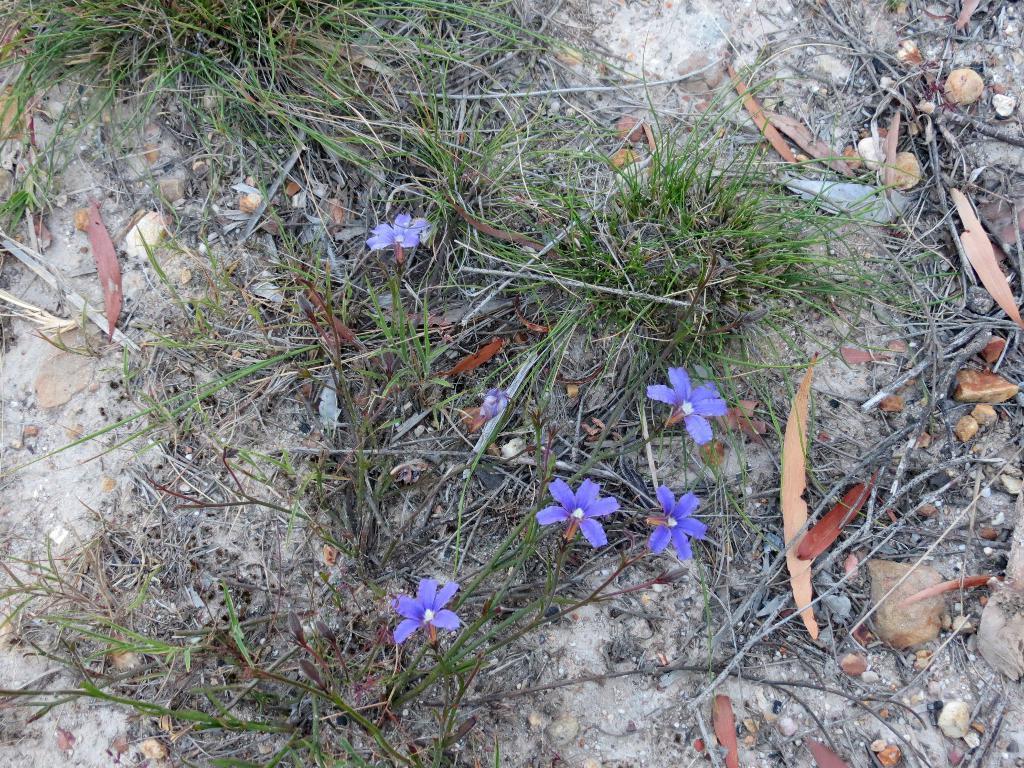Please provide a concise description of this image. There are purple color flowers, grass and dry leaves. 